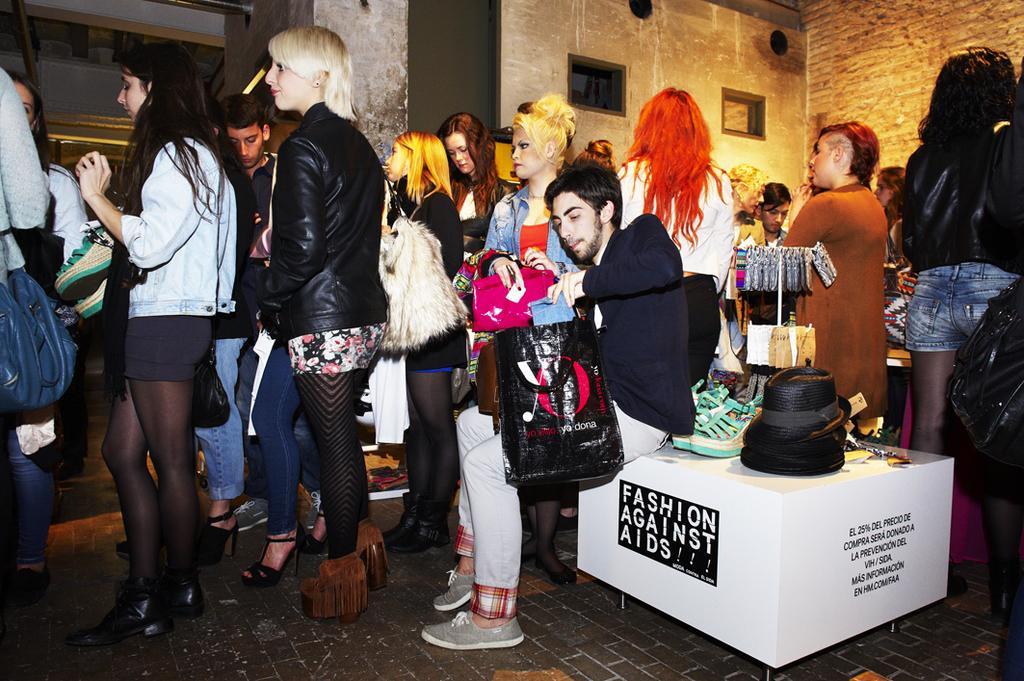Describe this image in one or two sentences. In this image we can see group of persons standing on the floor. On the right side of the image we can see table and some objects on it. In the background there are ventilators, holes and wall. 